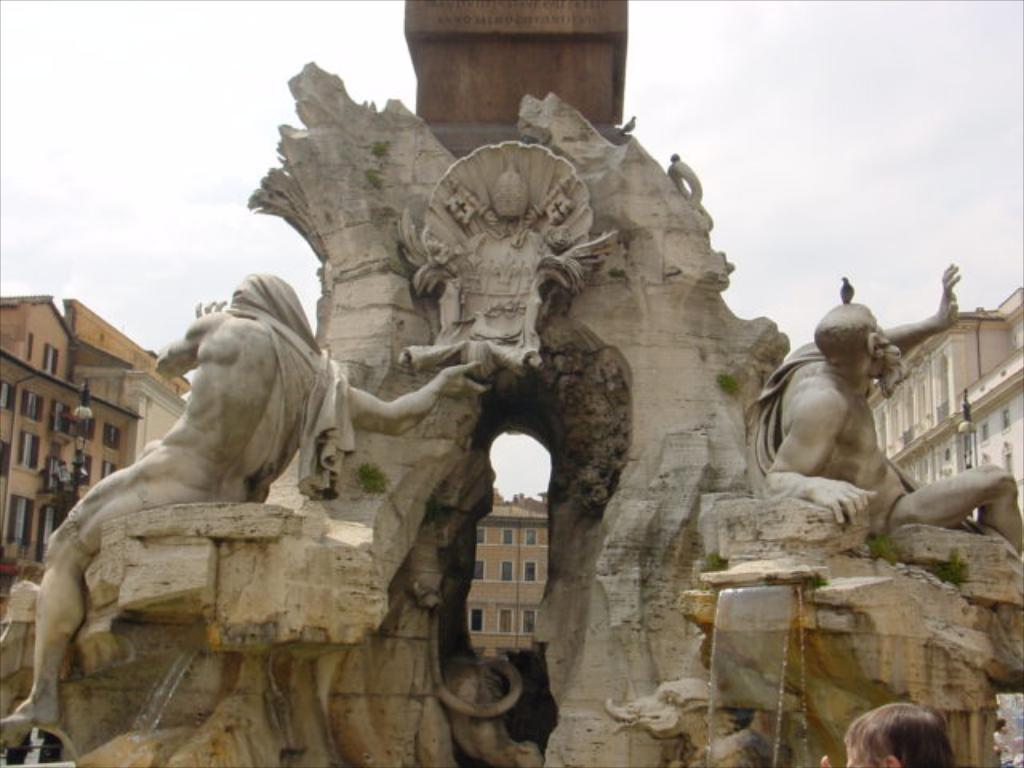What is the main feature in the image? There is a fountain with statues in the image. What can be seen in the background of the image? There are buildings, walls, windows, and streetlights in the background of the image. What is visible in the sky in the image? The sky is visible in the background of the image. What type of brass instrument is being taught by the teacher in the image? There is no teacher or brass instrument present in the image; it features a fountain with statues and various background elements. 